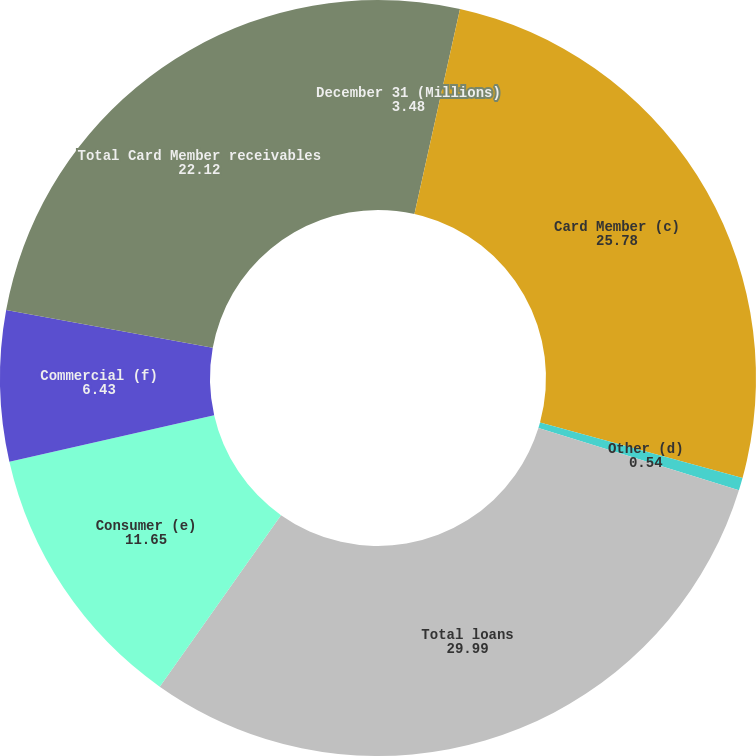Convert chart to OTSL. <chart><loc_0><loc_0><loc_500><loc_500><pie_chart><fcel>December 31 (Millions)<fcel>Card Member (c)<fcel>Other (d)<fcel>Total loans<fcel>Consumer (e)<fcel>Commercial (f)<fcel>Total Card Member receivables<nl><fcel>3.48%<fcel>25.78%<fcel>0.54%<fcel>29.99%<fcel>11.65%<fcel>6.43%<fcel>22.12%<nl></chart> 